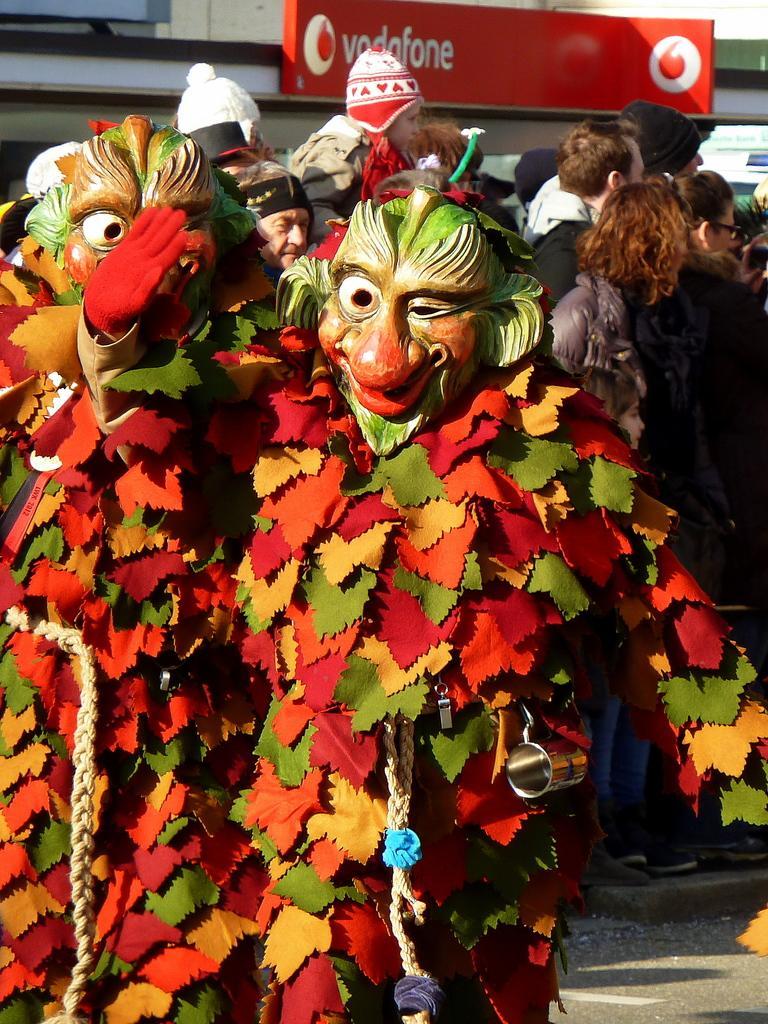Can you describe this image briefly? In this image I can see two persons and they are wearing different color costumes. Background I can see group of people standing, the board in red color and I can see the building in cream color. 